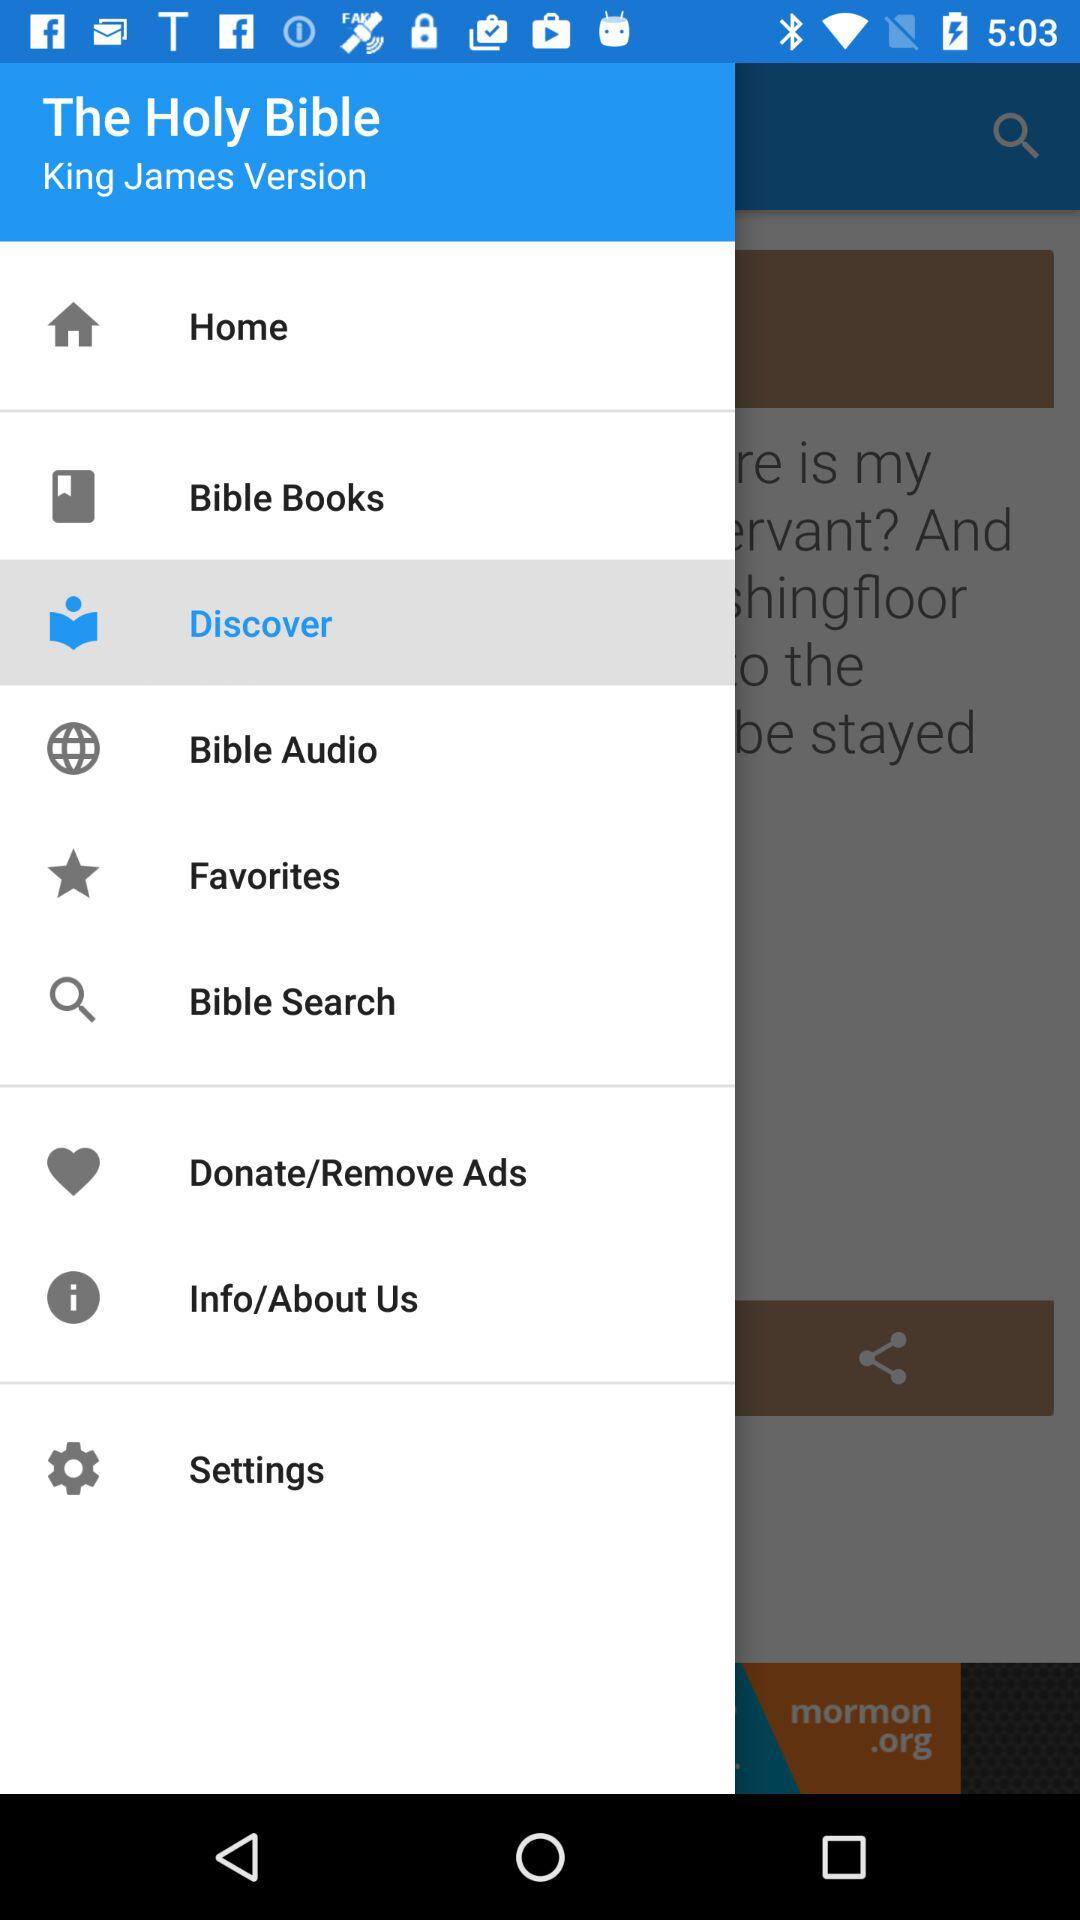Which version of "The Holy Bible" is this? The version of "The Holy Bible" is the "King James Version". 